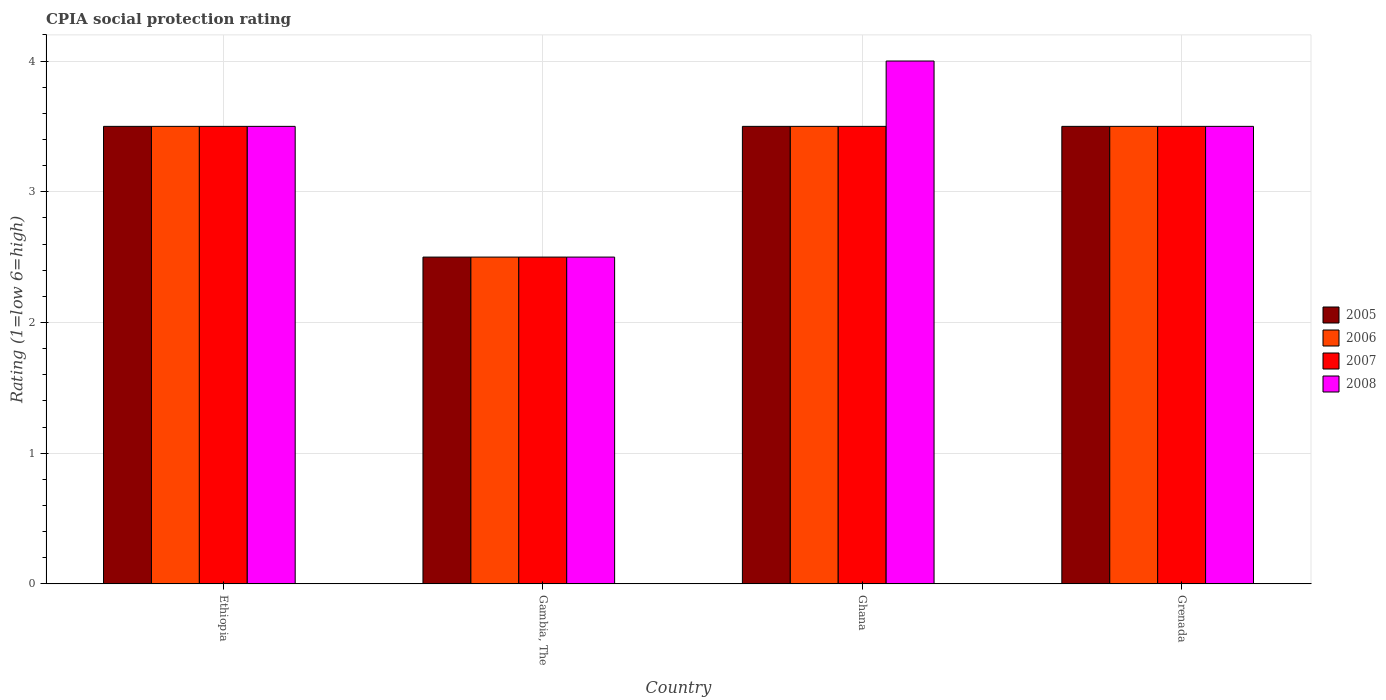How many different coloured bars are there?
Your answer should be compact. 4. Are the number of bars per tick equal to the number of legend labels?
Give a very brief answer. Yes. Are the number of bars on each tick of the X-axis equal?
Provide a succinct answer. Yes. How many bars are there on the 2nd tick from the left?
Provide a succinct answer. 4. Across all countries, what is the maximum CPIA rating in 2007?
Your answer should be compact. 3.5. In which country was the CPIA rating in 2005 maximum?
Offer a terse response. Ethiopia. In which country was the CPIA rating in 2005 minimum?
Your answer should be compact. Gambia, The. What is the total CPIA rating in 2005 in the graph?
Give a very brief answer. 13. What is the difference between the CPIA rating in 2006 in Ethiopia and that in Grenada?
Keep it short and to the point. 0. What is the difference between the CPIA rating of/in 2008 and CPIA rating of/in 2007 in Ethiopia?
Offer a terse response. 0. In how many countries, is the CPIA rating in 2006 greater than 3.4?
Your answer should be very brief. 3. What is the ratio of the CPIA rating in 2008 in Ethiopia to that in Gambia, The?
Give a very brief answer. 1.4. Is the CPIA rating in 2007 in Ethiopia less than that in Grenada?
Ensure brevity in your answer.  No. What is the difference between the highest and the second highest CPIA rating in 2008?
Your response must be concise. -0.5. Is it the case that in every country, the sum of the CPIA rating in 2006 and CPIA rating in 2007 is greater than the sum of CPIA rating in 2005 and CPIA rating in 2008?
Offer a very short reply. No. What does the 2nd bar from the right in Grenada represents?
Keep it short and to the point. 2007. Is it the case that in every country, the sum of the CPIA rating in 2007 and CPIA rating in 2008 is greater than the CPIA rating in 2005?
Your response must be concise. Yes. Are all the bars in the graph horizontal?
Give a very brief answer. No. Are the values on the major ticks of Y-axis written in scientific E-notation?
Your answer should be very brief. No. Does the graph contain any zero values?
Give a very brief answer. No. Does the graph contain grids?
Provide a short and direct response. Yes. Where does the legend appear in the graph?
Your response must be concise. Center right. What is the title of the graph?
Keep it short and to the point. CPIA social protection rating. What is the Rating (1=low 6=high) in 2006 in Ethiopia?
Keep it short and to the point. 3.5. What is the Rating (1=low 6=high) in 2006 in Gambia, The?
Provide a succinct answer. 2.5. What is the Rating (1=low 6=high) in 2007 in Gambia, The?
Give a very brief answer. 2.5. What is the Rating (1=low 6=high) of 2007 in Ghana?
Your answer should be compact. 3.5. What is the Rating (1=low 6=high) in 2008 in Ghana?
Offer a very short reply. 4. What is the Rating (1=low 6=high) in 2005 in Grenada?
Keep it short and to the point. 3.5. What is the Rating (1=low 6=high) in 2006 in Grenada?
Ensure brevity in your answer.  3.5. What is the Rating (1=low 6=high) in 2008 in Grenada?
Keep it short and to the point. 3.5. Across all countries, what is the maximum Rating (1=low 6=high) in 2005?
Your answer should be compact. 3.5. Across all countries, what is the maximum Rating (1=low 6=high) of 2006?
Ensure brevity in your answer.  3.5. Across all countries, what is the maximum Rating (1=low 6=high) in 2007?
Give a very brief answer. 3.5. Across all countries, what is the minimum Rating (1=low 6=high) in 2007?
Your answer should be compact. 2.5. Across all countries, what is the minimum Rating (1=low 6=high) in 2008?
Give a very brief answer. 2.5. What is the total Rating (1=low 6=high) in 2005 in the graph?
Provide a short and direct response. 13. What is the total Rating (1=low 6=high) of 2007 in the graph?
Ensure brevity in your answer.  13. What is the difference between the Rating (1=low 6=high) of 2005 in Ethiopia and that in Ghana?
Ensure brevity in your answer.  0. What is the difference between the Rating (1=low 6=high) of 2006 in Ethiopia and that in Ghana?
Provide a succinct answer. 0. What is the difference between the Rating (1=low 6=high) of 2008 in Ethiopia and that in Ghana?
Your response must be concise. -0.5. What is the difference between the Rating (1=low 6=high) of 2005 in Ethiopia and that in Grenada?
Your answer should be very brief. 0. What is the difference between the Rating (1=low 6=high) of 2006 in Ethiopia and that in Grenada?
Your response must be concise. 0. What is the difference between the Rating (1=low 6=high) of 2007 in Ethiopia and that in Grenada?
Offer a very short reply. 0. What is the difference between the Rating (1=low 6=high) of 2008 in Ethiopia and that in Grenada?
Provide a short and direct response. 0. What is the difference between the Rating (1=low 6=high) in 2005 in Gambia, The and that in Ghana?
Keep it short and to the point. -1. What is the difference between the Rating (1=low 6=high) in 2008 in Gambia, The and that in Ghana?
Provide a short and direct response. -1.5. What is the difference between the Rating (1=low 6=high) in 2008 in Gambia, The and that in Grenada?
Offer a terse response. -1. What is the difference between the Rating (1=low 6=high) of 2006 in Ethiopia and the Rating (1=low 6=high) of 2007 in Gambia, The?
Your answer should be compact. 1. What is the difference between the Rating (1=low 6=high) in 2006 in Ethiopia and the Rating (1=low 6=high) in 2008 in Gambia, The?
Your answer should be compact. 1. What is the difference between the Rating (1=low 6=high) of 2005 in Ethiopia and the Rating (1=low 6=high) of 2006 in Ghana?
Your response must be concise. 0. What is the difference between the Rating (1=low 6=high) in 2005 in Ethiopia and the Rating (1=low 6=high) in 2007 in Ghana?
Your answer should be very brief. 0. What is the difference between the Rating (1=low 6=high) in 2006 in Ethiopia and the Rating (1=low 6=high) in 2007 in Ghana?
Offer a very short reply. 0. What is the difference between the Rating (1=low 6=high) in 2005 in Ethiopia and the Rating (1=low 6=high) in 2006 in Grenada?
Offer a very short reply. 0. What is the difference between the Rating (1=low 6=high) in 2005 in Ethiopia and the Rating (1=low 6=high) in 2008 in Grenada?
Provide a succinct answer. 0. What is the difference between the Rating (1=low 6=high) of 2006 in Ethiopia and the Rating (1=low 6=high) of 2007 in Grenada?
Offer a very short reply. 0. What is the difference between the Rating (1=low 6=high) of 2006 in Ethiopia and the Rating (1=low 6=high) of 2008 in Grenada?
Make the answer very short. 0. What is the difference between the Rating (1=low 6=high) in 2005 in Gambia, The and the Rating (1=low 6=high) in 2007 in Ghana?
Give a very brief answer. -1. What is the difference between the Rating (1=low 6=high) in 2005 in Gambia, The and the Rating (1=low 6=high) in 2008 in Ghana?
Give a very brief answer. -1.5. What is the difference between the Rating (1=low 6=high) in 2006 in Gambia, The and the Rating (1=low 6=high) in 2007 in Ghana?
Give a very brief answer. -1. What is the difference between the Rating (1=low 6=high) in 2006 in Gambia, The and the Rating (1=low 6=high) in 2008 in Ghana?
Offer a terse response. -1.5. What is the difference between the Rating (1=low 6=high) of 2005 in Gambia, The and the Rating (1=low 6=high) of 2006 in Grenada?
Offer a very short reply. -1. What is the difference between the Rating (1=low 6=high) in 2006 in Gambia, The and the Rating (1=low 6=high) in 2007 in Grenada?
Offer a terse response. -1. What is the difference between the Rating (1=low 6=high) in 2006 in Gambia, The and the Rating (1=low 6=high) in 2008 in Grenada?
Your answer should be compact. -1. What is the difference between the Rating (1=low 6=high) in 2005 in Ghana and the Rating (1=low 6=high) in 2006 in Grenada?
Make the answer very short. 0. What is the difference between the Rating (1=low 6=high) in 2005 in Ghana and the Rating (1=low 6=high) in 2007 in Grenada?
Your response must be concise. 0. What is the difference between the Rating (1=low 6=high) of 2006 in Ghana and the Rating (1=low 6=high) of 2008 in Grenada?
Your answer should be very brief. 0. What is the difference between the Rating (1=low 6=high) in 2007 in Ghana and the Rating (1=low 6=high) in 2008 in Grenada?
Give a very brief answer. 0. What is the average Rating (1=low 6=high) of 2006 per country?
Give a very brief answer. 3.25. What is the average Rating (1=low 6=high) of 2007 per country?
Offer a terse response. 3.25. What is the average Rating (1=low 6=high) of 2008 per country?
Provide a succinct answer. 3.38. What is the difference between the Rating (1=low 6=high) in 2005 and Rating (1=low 6=high) in 2007 in Ethiopia?
Your response must be concise. 0. What is the difference between the Rating (1=low 6=high) in 2005 and Rating (1=low 6=high) in 2008 in Ethiopia?
Keep it short and to the point. 0. What is the difference between the Rating (1=low 6=high) of 2006 and Rating (1=low 6=high) of 2007 in Ethiopia?
Make the answer very short. 0. What is the difference between the Rating (1=low 6=high) of 2006 and Rating (1=low 6=high) of 2008 in Ethiopia?
Offer a terse response. 0. What is the difference between the Rating (1=low 6=high) in 2005 and Rating (1=low 6=high) in 2007 in Gambia, The?
Provide a succinct answer. 0. What is the difference between the Rating (1=low 6=high) of 2005 and Rating (1=low 6=high) of 2008 in Gambia, The?
Offer a terse response. 0. What is the difference between the Rating (1=low 6=high) in 2006 and Rating (1=low 6=high) in 2008 in Gambia, The?
Provide a succinct answer. 0. What is the difference between the Rating (1=low 6=high) of 2005 and Rating (1=low 6=high) of 2006 in Ghana?
Your answer should be very brief. 0. What is the difference between the Rating (1=low 6=high) in 2005 and Rating (1=low 6=high) in 2007 in Ghana?
Ensure brevity in your answer.  0. What is the difference between the Rating (1=low 6=high) of 2005 and Rating (1=low 6=high) of 2008 in Ghana?
Your response must be concise. -0.5. What is the difference between the Rating (1=low 6=high) of 2006 and Rating (1=low 6=high) of 2007 in Ghana?
Your response must be concise. 0. What is the difference between the Rating (1=low 6=high) of 2006 and Rating (1=low 6=high) of 2008 in Ghana?
Keep it short and to the point. -0.5. What is the difference between the Rating (1=low 6=high) of 2005 and Rating (1=low 6=high) of 2007 in Grenada?
Ensure brevity in your answer.  0. What is the difference between the Rating (1=low 6=high) in 2007 and Rating (1=low 6=high) in 2008 in Grenada?
Ensure brevity in your answer.  0. What is the ratio of the Rating (1=low 6=high) of 2005 in Ethiopia to that in Gambia, The?
Provide a short and direct response. 1.4. What is the ratio of the Rating (1=low 6=high) of 2007 in Ethiopia to that in Gambia, The?
Ensure brevity in your answer.  1.4. What is the ratio of the Rating (1=low 6=high) in 2008 in Ethiopia to that in Gambia, The?
Your answer should be very brief. 1.4. What is the ratio of the Rating (1=low 6=high) of 2006 in Ethiopia to that in Ghana?
Your answer should be very brief. 1. What is the ratio of the Rating (1=low 6=high) of 2008 in Ethiopia to that in Ghana?
Keep it short and to the point. 0.88. What is the ratio of the Rating (1=low 6=high) of 2005 in Ethiopia to that in Grenada?
Give a very brief answer. 1. What is the ratio of the Rating (1=low 6=high) in 2008 in Ethiopia to that in Grenada?
Keep it short and to the point. 1. What is the ratio of the Rating (1=low 6=high) of 2008 in Gambia, The to that in Ghana?
Provide a succinct answer. 0.62. What is the ratio of the Rating (1=low 6=high) of 2005 in Gambia, The to that in Grenada?
Provide a short and direct response. 0.71. What is the ratio of the Rating (1=low 6=high) of 2007 in Gambia, The to that in Grenada?
Provide a succinct answer. 0.71. What is the ratio of the Rating (1=low 6=high) in 2006 in Ghana to that in Grenada?
Your answer should be very brief. 1. What is the difference between the highest and the second highest Rating (1=low 6=high) in 2006?
Give a very brief answer. 0. What is the difference between the highest and the second highest Rating (1=low 6=high) in 2007?
Ensure brevity in your answer.  0. What is the difference between the highest and the second highest Rating (1=low 6=high) of 2008?
Give a very brief answer. 0.5. 